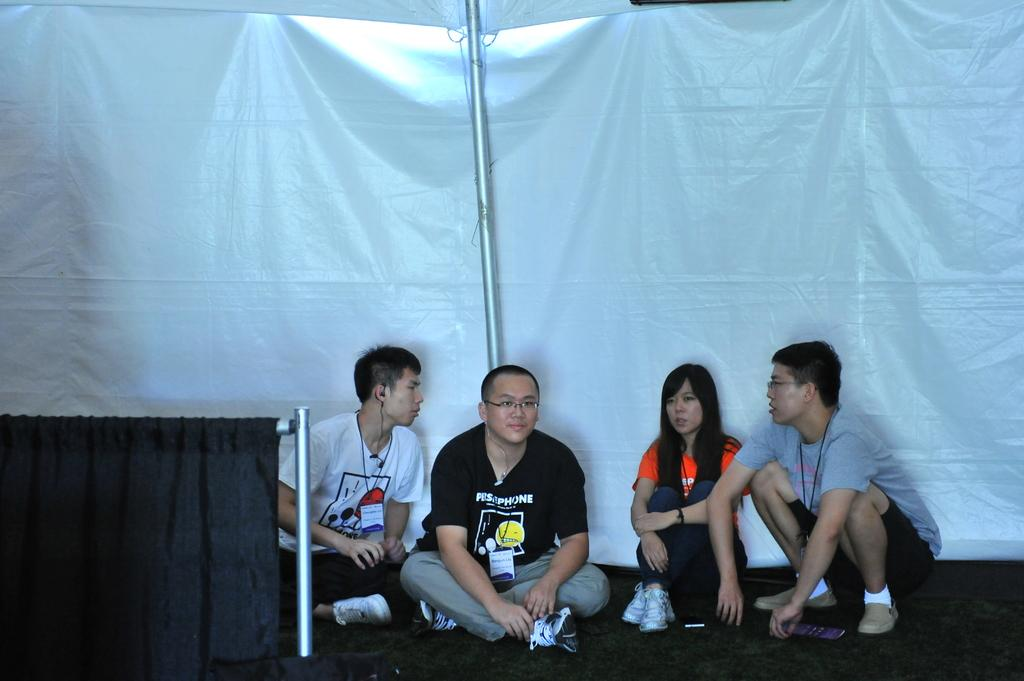How many people are sitting on the floor in the image? There are four persons sitting on the floor in the image. What can be seen in the image besides the people sitting on the floor? There is a pole and a black curtain in the image. What is present in the background of the image? There is a tarpaulin sheet in the background of the image. What type of screw is being used to hold the tarpaulin sheet in place in the image? There is no screw visible in the image, and the tarpaulin sheet is not being held in place by any screws. Can you describe the servant attending to the persons sitting on the floor in the image? There is no servant present in the image; it only shows four persons sitting on the floor. 